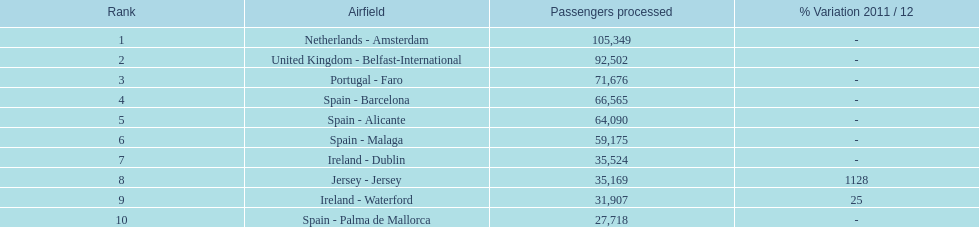Which airport has no more than 30,000 passengers handled among the 10 busiest routes to and from london southend airport in 2012? Spain - Palma de Mallorca. 